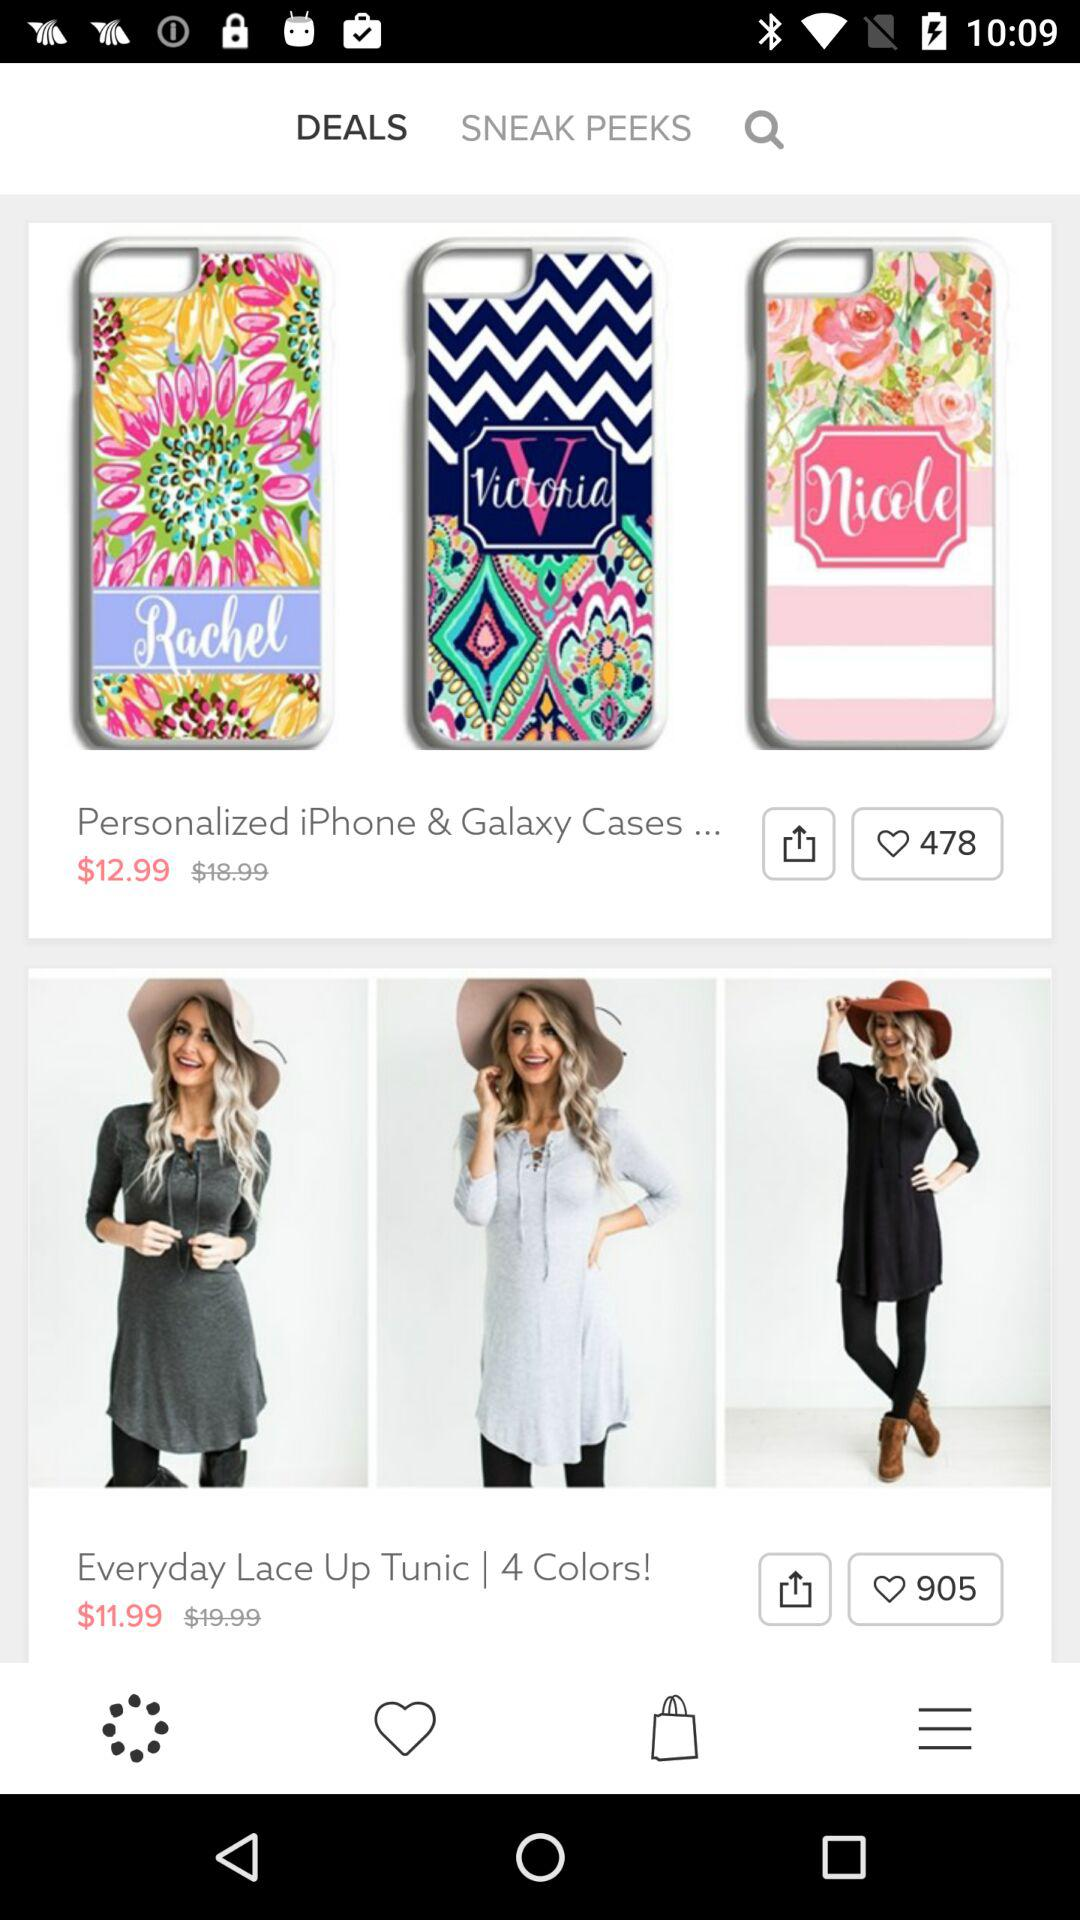How many likes are there on the "iPhone & Galaxy Cases"? There are 478 likes. 